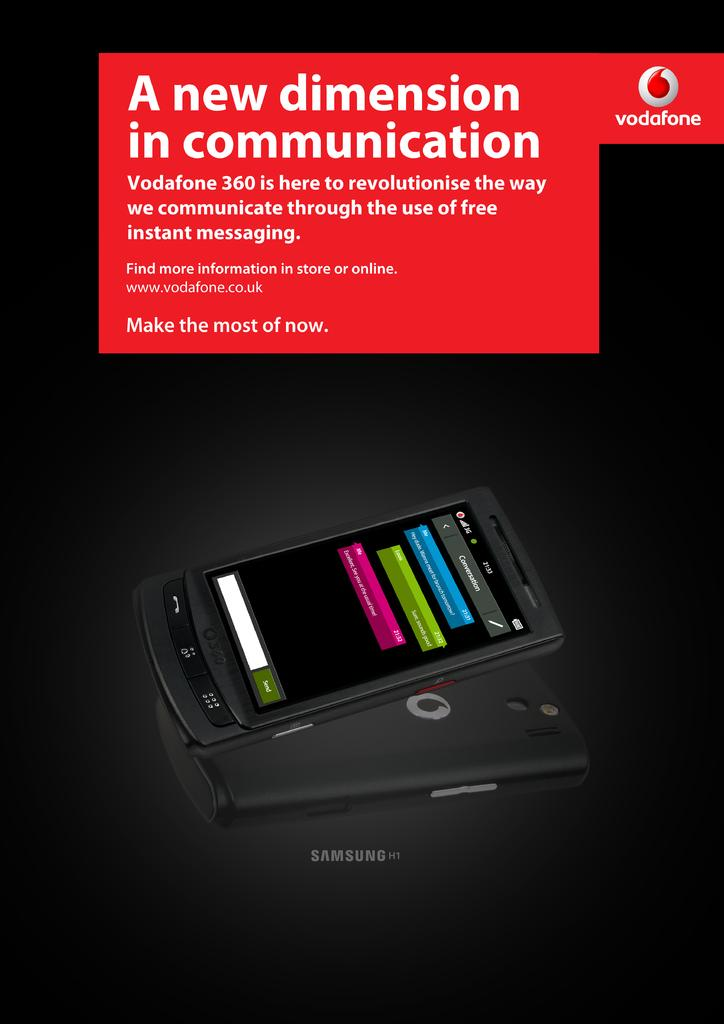<image>
Render a clear and concise summary of the photo. a samsung phone that talks of it's features having a new dimension of communication 